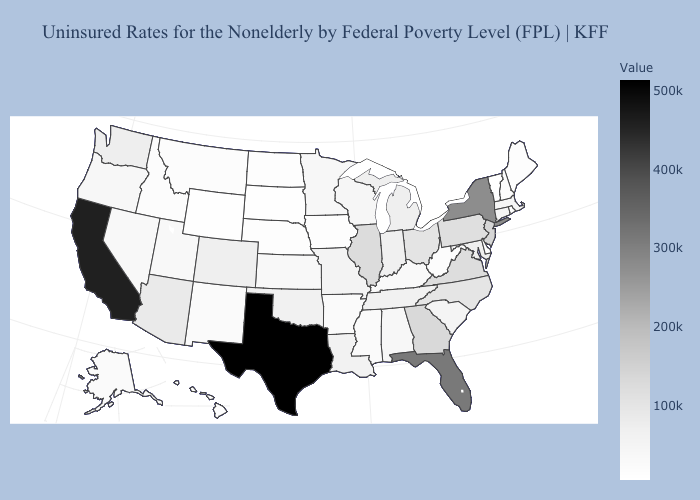Is the legend a continuous bar?
Give a very brief answer. Yes. Does Texas have the highest value in the South?
Write a very short answer. Yes. Which states have the lowest value in the USA?
Keep it brief. Vermont. 